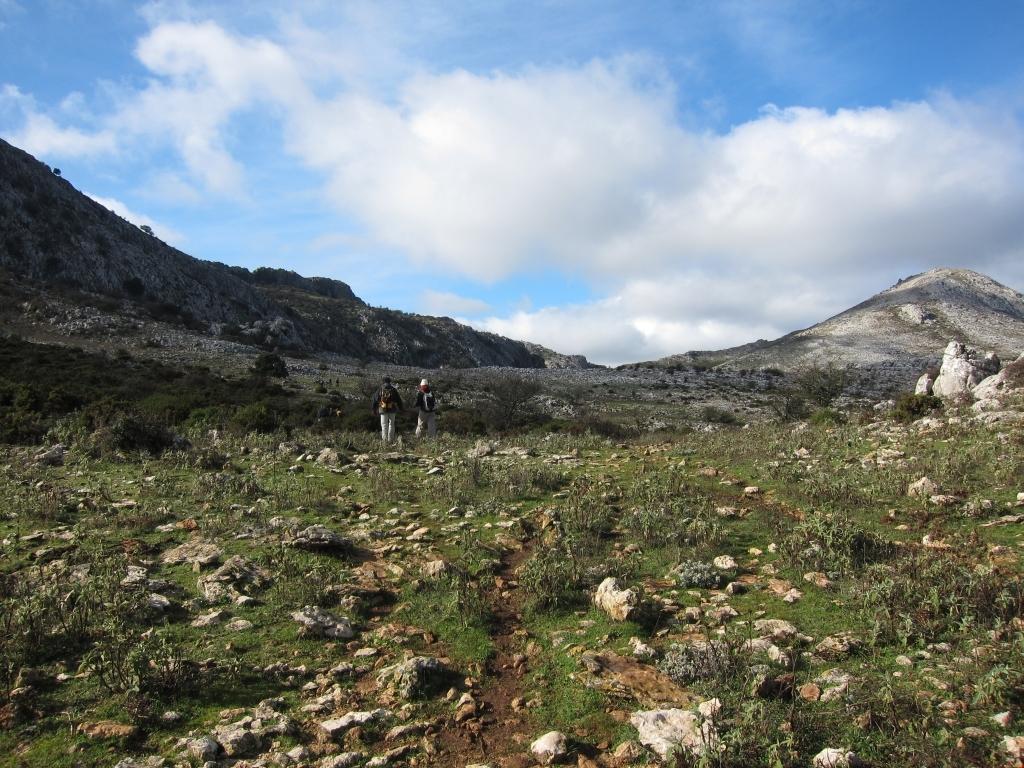How would you summarize this image in a sentence or two? In this image in the center there are two persons who are standing and at the bottom there is grass and some rocks, in the background there are some mountains. At the top of the image there is sky. 